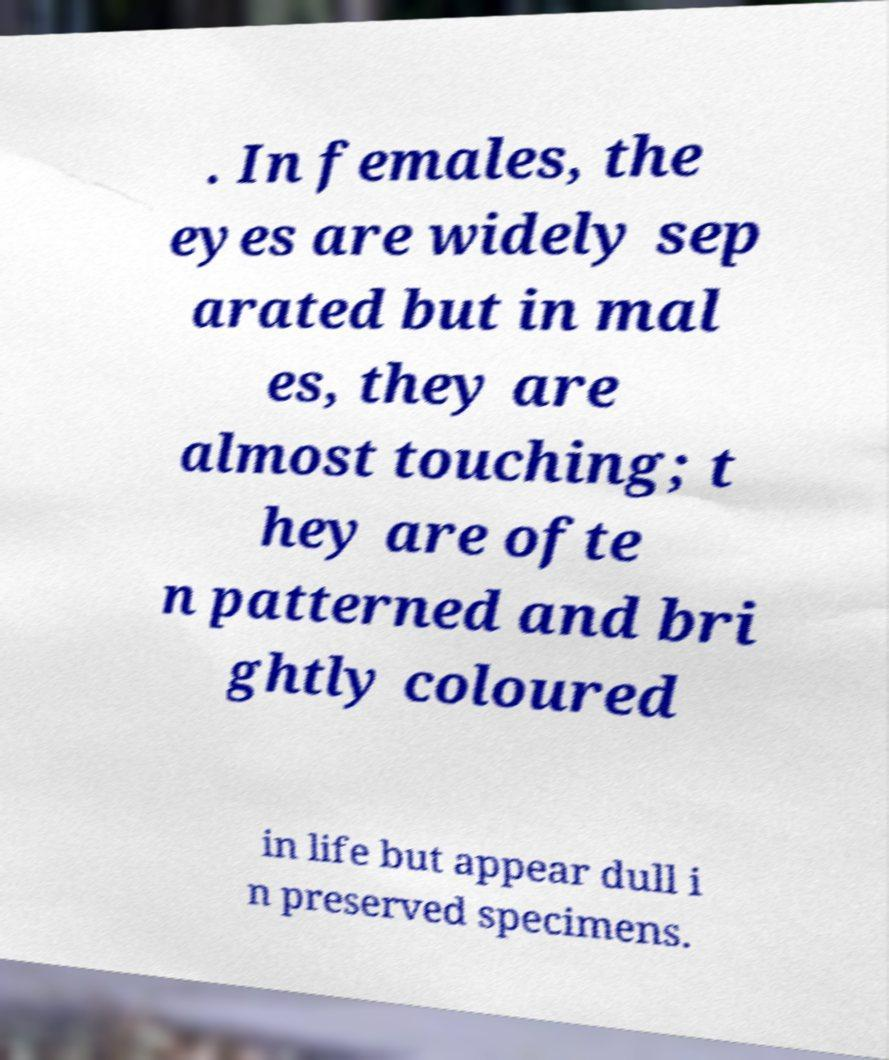Could you assist in decoding the text presented in this image and type it out clearly? . In females, the eyes are widely sep arated but in mal es, they are almost touching; t hey are ofte n patterned and bri ghtly coloured in life but appear dull i n preserved specimens. 